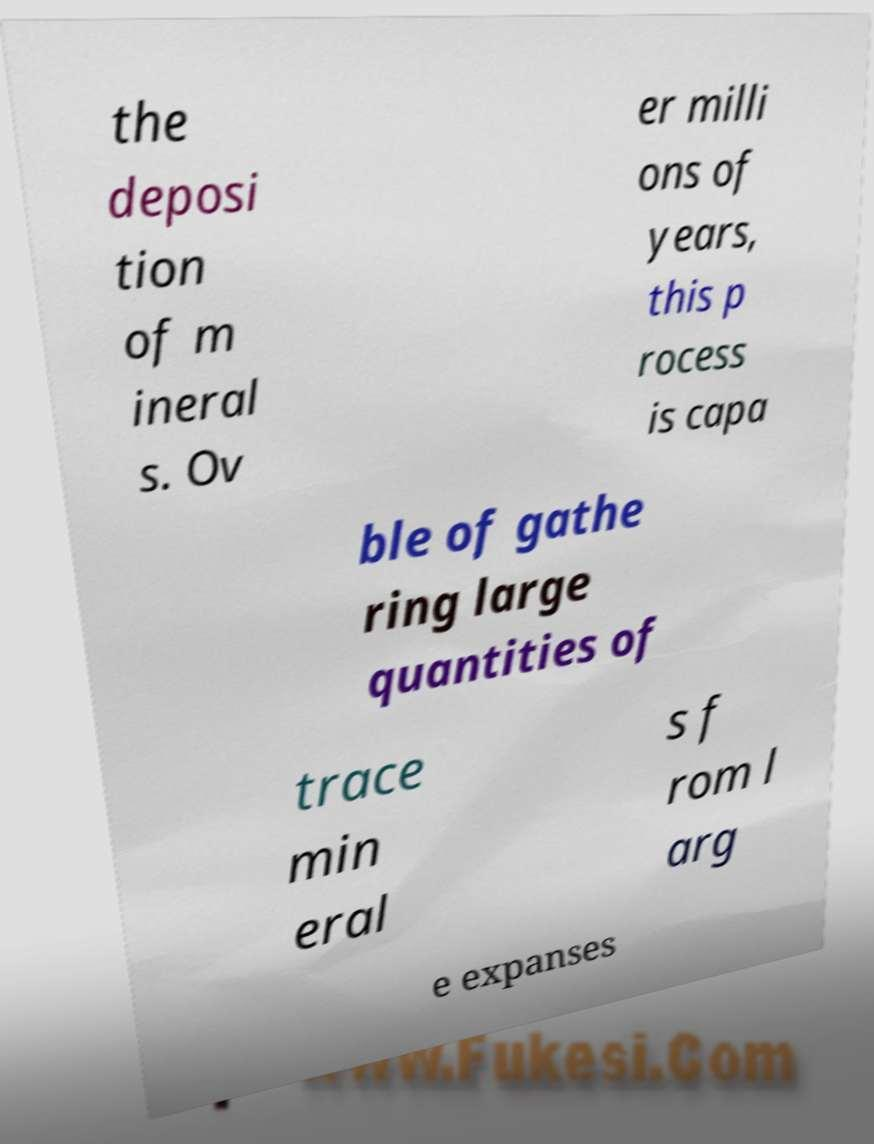Can you accurately transcribe the text from the provided image for me? the deposi tion of m ineral s. Ov er milli ons of years, this p rocess is capa ble of gathe ring large quantities of trace min eral s f rom l arg e expanses 